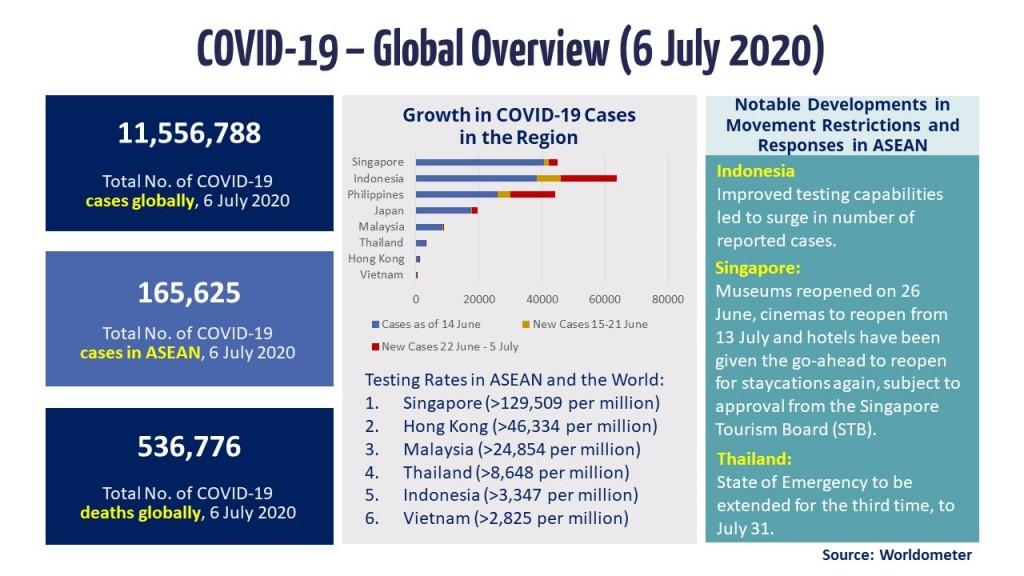Specify some key components in this picture. As of July 6, 2020, there have been a total of 165,625 COVID-19 cases reported in ASEAN. Singapore has reported the highest number of COVID-19 cases among ASEAN countries as of 14 June 2020. Vietnam has reported the least number of COVID-19 cases among all ASEAN countries as of 14 June 2020, according to reported data. As of July 6, 2020, the COVID-19 testing rate in Malaysia was greater than 24,854 per million, indicating a high level of testing activity in the country. As of July 6th, 2020, the global total number of COVID-19 deaths was 536,776. 